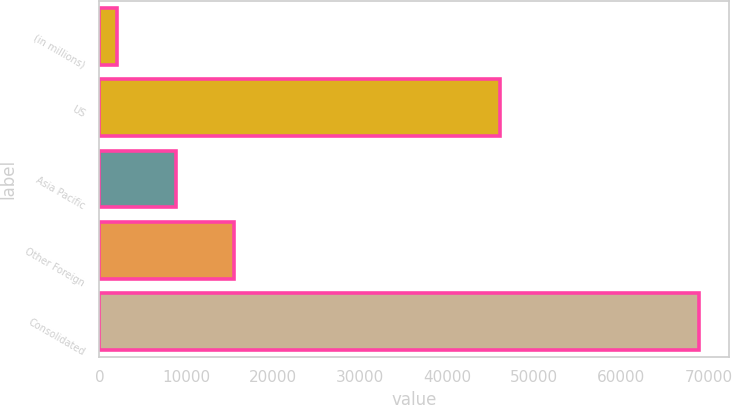<chart> <loc_0><loc_0><loc_500><loc_500><bar_chart><fcel>(in millions)<fcel>US<fcel>Asia Pacific<fcel>Other Foreign<fcel>Consolidated<nl><fcel>2013<fcel>46078<fcel>8804<fcel>15490.1<fcel>68874<nl></chart> 